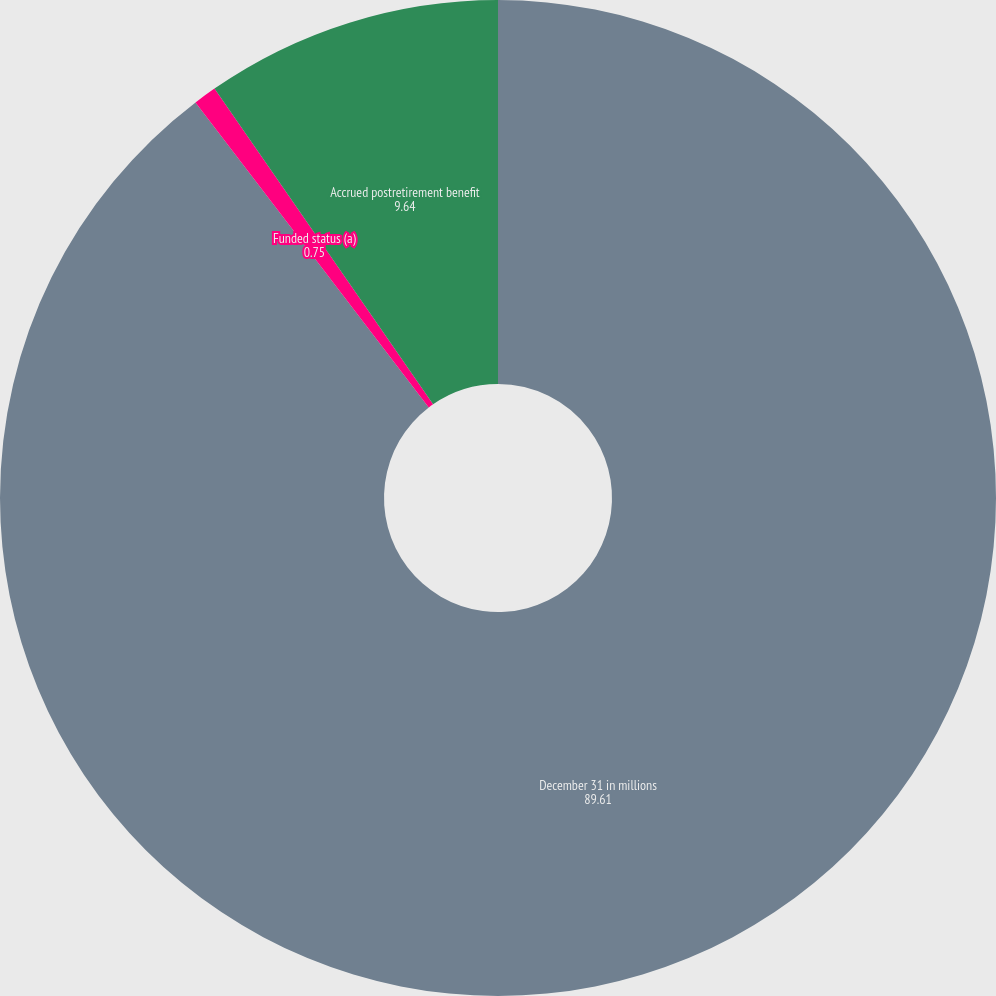Convert chart to OTSL. <chart><loc_0><loc_0><loc_500><loc_500><pie_chart><fcel>December 31 in millions<fcel>Funded status (a)<fcel>Accrued postretirement benefit<nl><fcel>89.61%<fcel>0.75%<fcel>9.64%<nl></chart> 